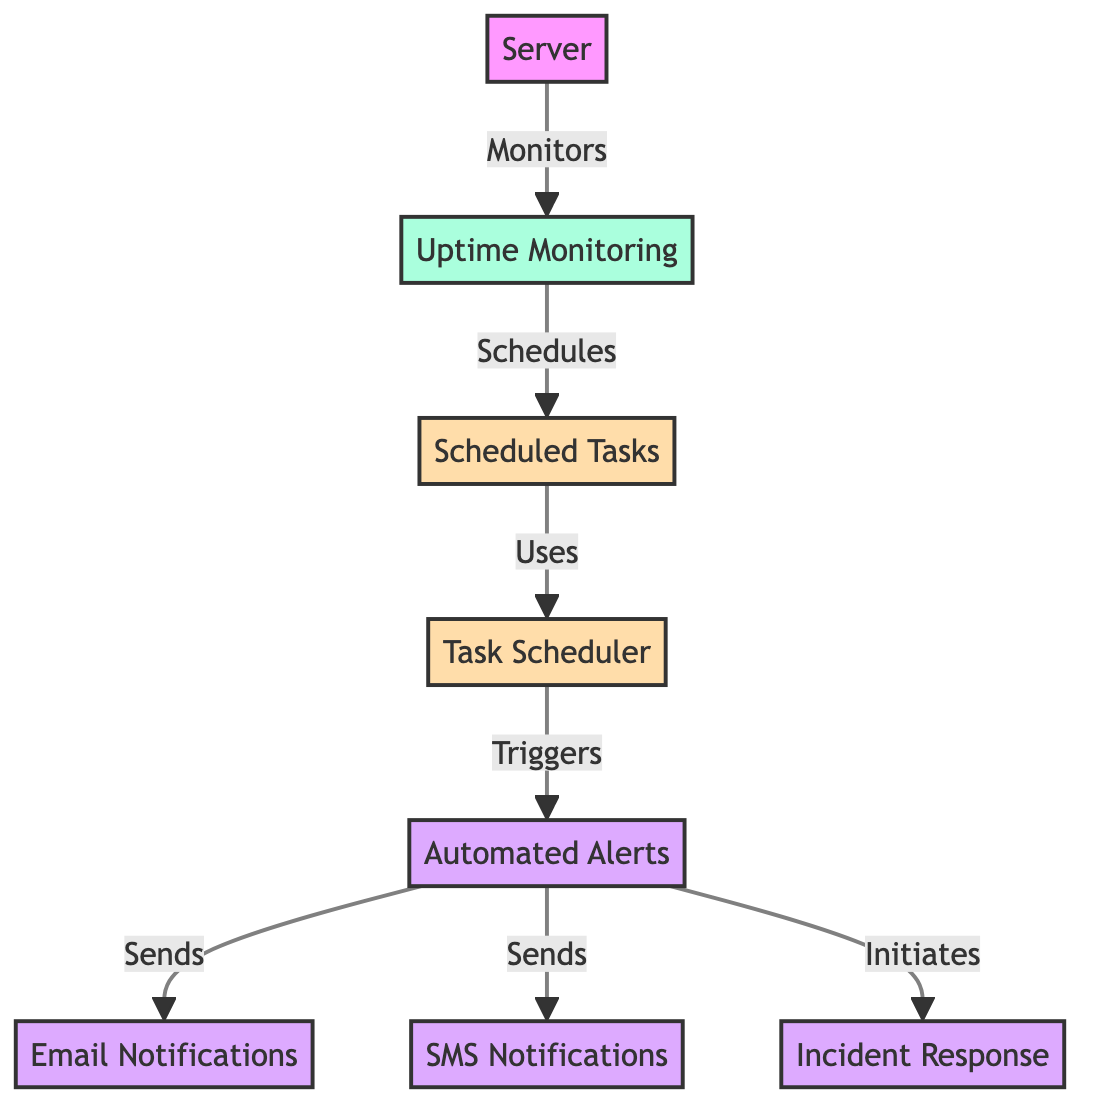What node is responsible for monitoring uptime? The diagram indicates that "Uptime Monitoring" is the node that is responsible for monitoring the uptime of the server, as it is directly linked to the "Server" node with the label "Monitors."
Answer: Uptime Monitoring How many types of notifications are sent by the alerts? The diagram shows two types of notifications being sent by the "alerts" node: "Email Notifications" and "SMS Notifications." Therefore, there are two types.
Answer: 2 What is the relationship between scheduled tasks and task scheduler? The diagram depicts that "Scheduled Tasks" uses the "Task Scheduler," as indicated by the directed arrow labeled "Uses" connecting the two nodes.
Answer: Uses What initiates the incident response? According to the diagram, "alerts" initiates the "Incident Response," suggesting that when alerts are triggered, an incident response process is started.
Answer: alerts How many total nodes are there in the diagram? By counting all the distinct nodes within the diagram, including "Server," "Uptime Monitoring," "Scheduled Tasks," "Task Scheduler," "Alerts," "Email Notifications," "SMS Notifications," and "Incident Response," we find there are a total of 8 nodes.
Answer: 8 What type of alerts are triggered by the task scheduler? The diagram outlines that the "Task Scheduler" triggers "alerts," indicating that the task scheduler is responsible for starting notifications or actions as a part of the monitoring process.
Answer: alerts Which node is scheduled by uptime monitoring? The diagram explicitly states "Scheduled Tasks" is the entity that is scheduled by "Uptime Monitoring," as illustrated by the line pointing from uptime monitoring to scheduled tasks with the label "Schedules."
Answer: Scheduled Tasks What flows from alerts to email notifications? The diagram shows that alerts sends messages or notifications to "Email Notifications," indicating a direct flow from alerts to email.
Answer: Sends 